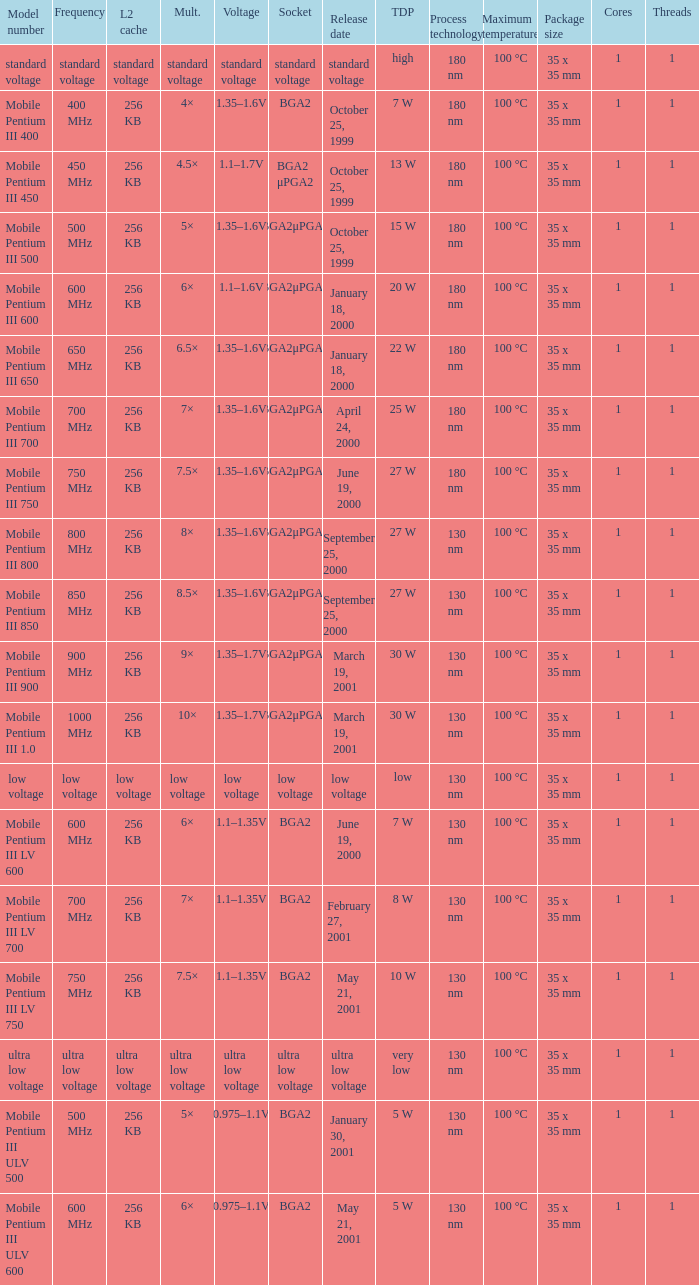What model number uses standard voltage socket? Standard voltage. 